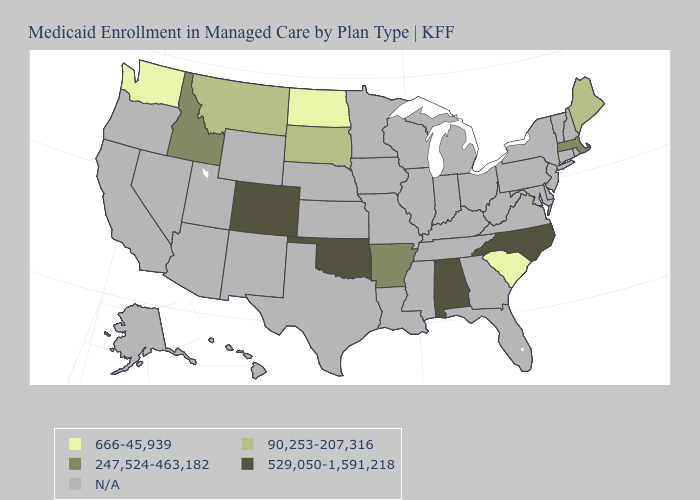Which states have the highest value in the USA?
Answer briefly. Alabama, Colorado, North Carolina, Oklahoma. Which states hav the highest value in the Northeast?
Be succinct. Massachusetts. What is the value of Illinois?
Be succinct. N/A. Name the states that have a value in the range 666-45,939?
Be succinct. North Dakota, South Carolina, Washington. What is the highest value in the USA?
Answer briefly. 529,050-1,591,218. Name the states that have a value in the range 529,050-1,591,218?
Quick response, please. Alabama, Colorado, North Carolina, Oklahoma. Does the first symbol in the legend represent the smallest category?
Keep it brief. Yes. Name the states that have a value in the range 247,524-463,182?
Write a very short answer. Arkansas, Idaho, Massachusetts. Does Maine have the lowest value in the Northeast?
Give a very brief answer. Yes. What is the highest value in the USA?
Be succinct. 529,050-1,591,218. Name the states that have a value in the range 666-45,939?
Give a very brief answer. North Dakota, South Carolina, Washington. What is the value of Hawaii?
Quick response, please. N/A. Name the states that have a value in the range 90,253-207,316?
Concise answer only. Maine, Montana, South Dakota. Name the states that have a value in the range 666-45,939?
Give a very brief answer. North Dakota, South Carolina, Washington. Name the states that have a value in the range 666-45,939?
Be succinct. North Dakota, South Carolina, Washington. 